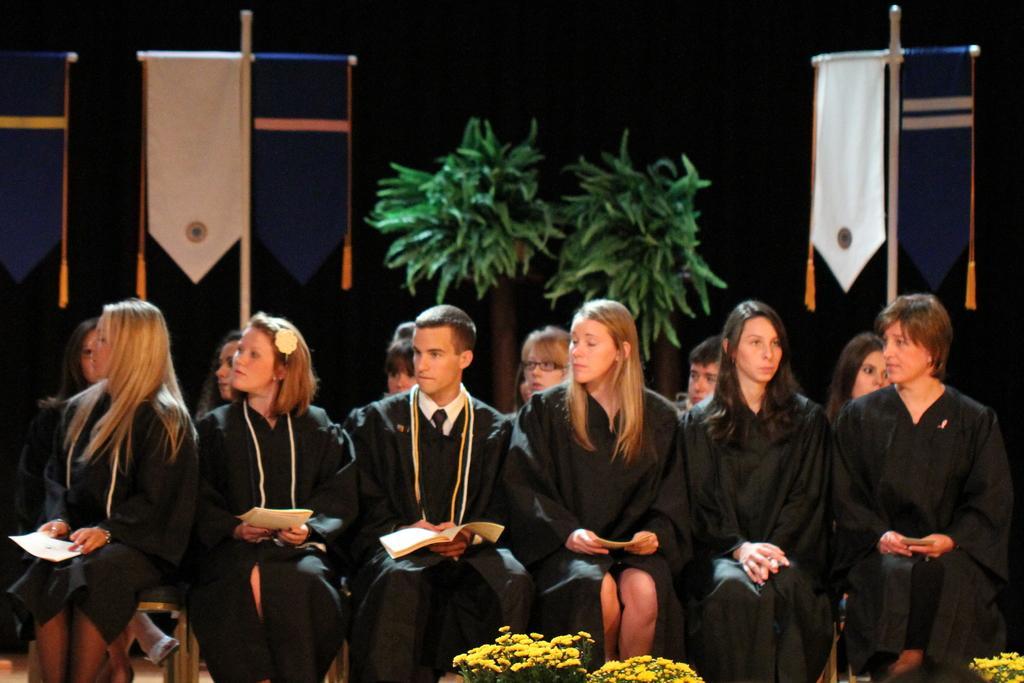Could you give a brief overview of what you see in this image? Here we can see group of people sitting on the chairs and they are holding books with their hands. There are flowers. Here we can see banners, poles, and plants. There is a dark background. 